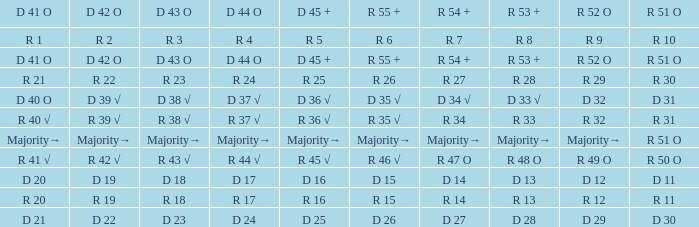Which R 51 O value corresponds to a D 42 O value of r 19? R 11. 